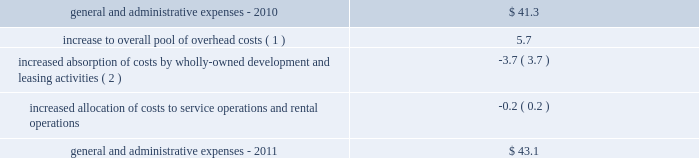32| | duke realty corporation annual report 2012 2022 in 2010 , we sold approximately 60 acres of land , in two separate transactions , which resulted in impairment charges of $ 9.8 million .
These sales were opportunistic in nature and we had not identified or actively marketed this land for disposition , as it was previously intended to be held for development .
General and administrative expenses general and administrative expenses increased from $ 41.3 million in 2010 to $ 43.1 million in 2011 .
The table sets forth the factors that led to the increase in general and administrative expenses from 2010 to 2011 ( in millions ) : .
Interest expense interest expense from continuing operations increased from $ 186.4 million in 2010 to $ 220.5 million in 2011 .
The increase was primarily a result of increased average outstanding debt during 2011 compared to 2010 , which was driven by our acquisition activities as well as other uses of capital .
A $ 7.2 million decrease in the capitalization of interest costs , the result of developed properties no longer meeting the criteria for interest capitalization , also contributed to the increase in interest expense .
Gain ( loss ) on debt transactions there were no gains or losses on debt transactions during 2011 .
During 2010 , through a cash tender offer and open market transactions , we repurchased certain of our outstanding series of unsecured notes scheduled to mature in 2011 and 2013 .
In total , we paid $ 292.2 million for unsecured notes that had a face value of $ 279.9 million .
We recognized a net loss on extinguishment of $ 16.3 million after considering the write-off of unamortized deferred financing costs , discounts and other accounting adjustments .
Acquisition-related activity during 2011 , we recognized approximately $ 2.3 million in acquisition costs , compared to $ 1.9 million of such costs in 2010 .
During 2011 , we also recognized a $ 1.1 million gain related to the acquisition of a building from one of our 50%-owned unconsolidated joint ventures , compared to a $ 57.7 million gain in 2010 on the acquisition of our joint venture partner 2019s 50% ( 50 % ) interest in dugan .
Critical accounting policies the preparation of our consolidated financial statements in conformity with gaap requires us to make estimates and assumptions that affect the reported amounts of assets and liabilities and disclosure of contingent assets and liabilities at the date of the financial statements and the reported amounts of revenues and expenses during the reported period .
Our estimates , judgments and assumptions are inherently subjective and based on the existing business and market conditions , and are therefore continually evaluated based upon available information and experience .
Note 2 to the consolidated financial statements includes further discussion of our significant accounting policies .
Our management has assessed the accounting policies used in the preparation of our financial statements and discussed them with our audit committee and independent auditors .
The following accounting policies are considered critical based upon materiality to the financial statements , degree of judgment involved in estimating reported amounts and sensitivity to changes in industry and economic conditions : ( 1 ) the increase to our overall pool of overhead costs from 2010 is largely due to increased severance pay related to overhead reductions that took place near the end of 2011 .
( 2 ) our total leasing activity increased and we also increased wholly owned development activities from 2010 .
We capitalized $ 25.3 million and $ 10.4 million of our total overhead costs to leasing and development , respectively , for consolidated properties during 2011 , compared to capitalizing $ 23.5 million and $ 8.5 million of such costs , respectively , for 2010 .
Combined overhead costs capitalized to leasing and development totaled 20.6% ( 20.6 % ) and 19.1% ( 19.1 % ) of our overall pool of overhead costs for 2011 and 2010 , respectively. .
What was the percentage increase in the general and administrative expenses from 2010 to 2011.\\n? 
Computations: ((43.1 - 41.3) / 41.3)
Answer: 0.04358. 